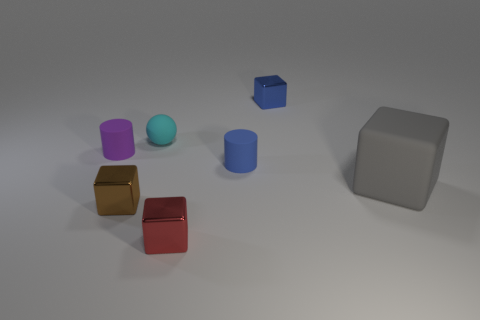There is a metallic block that is in front of the blue cylinder and to the right of the sphere; what size is it?
Provide a short and direct response. Small. Are there more small matte objects that are on the left side of the tiny cyan matte object than large purple rubber blocks?
Provide a succinct answer. Yes. What number of cubes are either brown objects or large things?
Your response must be concise. 2. There is a tiny metallic thing that is both in front of the large gray cube and behind the red metal cube; what is its shape?
Your answer should be compact. Cube. Is the number of tiny cubes that are behind the cyan rubber sphere the same as the number of cyan rubber balls to the right of the blue cube?
Provide a short and direct response. No. How many things are either big yellow rubber cylinders or small blue cylinders?
Ensure brevity in your answer.  1. The rubber ball that is the same size as the blue cylinder is what color?
Make the answer very short. Cyan. How many things are either tiny metal things that are behind the tiny red block or tiny matte cylinders that are right of the small brown object?
Keep it short and to the point. 3. Is the number of blue rubber cylinders that are behind the tiny red cube the same as the number of red shiny blocks?
Give a very brief answer. Yes. There is a metallic block that is behind the cyan rubber thing; is it the same size as the metallic thing that is in front of the tiny brown shiny block?
Make the answer very short. Yes. 